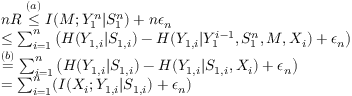<formula> <loc_0><loc_0><loc_500><loc_500>\begin{array} { r l } & { n R \overset { ( a ) } { \leq } I ( M ; Y _ { 1 } ^ { n } | S _ { 1 } ^ { n } ) + n \epsilon _ { n } } \\ & { \leq \sum _ { i = 1 } ^ { n } \left ( H ( Y _ { 1 , i } | S _ { 1 , i } ) - H ( Y _ { 1 , i } | Y _ { 1 } ^ { i - 1 } , S _ { 1 } ^ { n } , M , X _ { i } ) + \epsilon _ { n } \right ) } \\ & { \overset { ( b ) } { = } \sum _ { i = 1 } ^ { n } \left ( H ( Y _ { 1 , i } | S _ { 1 , i } ) - H ( Y _ { 1 , i } | S _ { 1 , i } , X _ { i } ) + \epsilon _ { n } \right ) } \\ & { = \sum _ { i = 1 } ^ { n } ( I ( X _ { i } ; Y _ { 1 , i } | S _ { 1 , i } ) + \epsilon _ { n } ) } \end{array}</formula> 